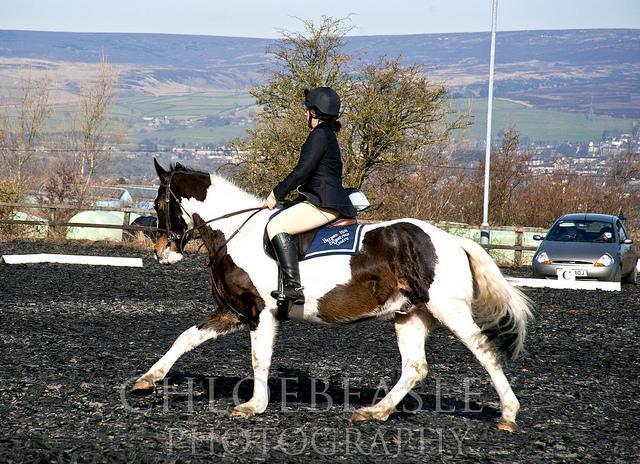How many cars?
Give a very brief answer. 1. 